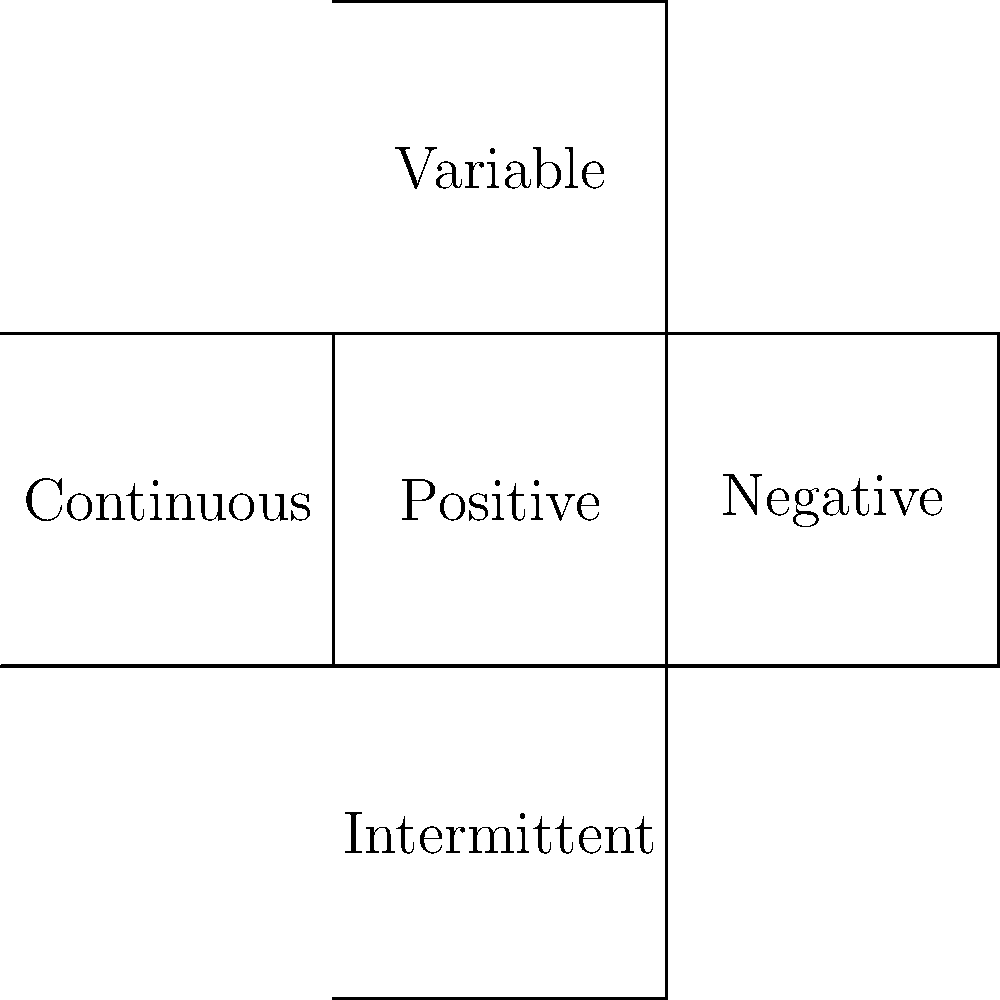The 2D net shown represents different types of reinforcement in behavioral psychology. If this net were folded into a 3D cube, which type of reinforcement would be opposite to "Positive" reinforcement? To solve this puzzle, we need to mentally fold the 2D net into a 3D cube and determine which face would be opposite to the "Positive" reinforcement face. Let's follow these steps:

1. Identify the "Positive" reinforcement face: It's the central square labeled "Positive".

2. Mentally fold the net:
   - The "Negative" face (right) folds to the right.
   - The "Variable" face (top) folds upwards.
   - The "Continuous" face (left) folds to the left.
   - The "Intermittent" face (bottom) folds downwards.

3. Determine the opposite face:
   - In a cube, opposite faces are those that are parallel and don't share any edges.
   - The face that would be opposite to "Positive" is the one that folds to be parallel to it without sharing any edges.

4. Identify the opposite face:
   - The "Intermittent" face, when folded, would be on the bottom of the cube, directly opposite to the "Positive" face on top.

Therefore, "Intermittent" reinforcement would be opposite to "Positive" reinforcement in this 3D representation.

This spatial reasoning exercise relates to the persona of a behavioral psychologist by incorporating different types of reinforcement, which are crucial concepts in understanding behavior modification and conditioning.
Answer: Intermittent reinforcement 